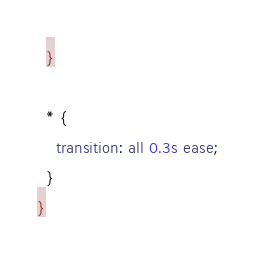<code> <loc_0><loc_0><loc_500><loc_500><_CSS_>  }

  * {
    transition: all 0.3s ease;
  }
}
</code> 